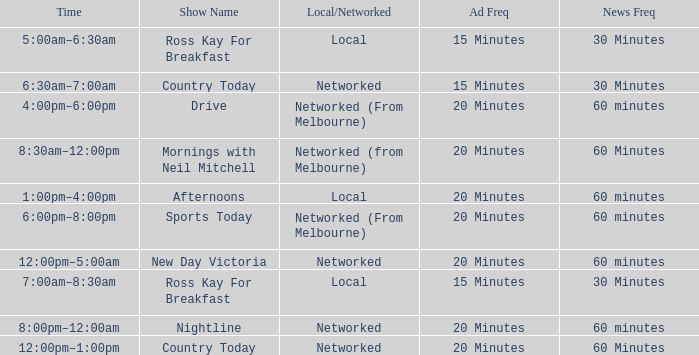What Time has a Show Name of mornings with neil mitchell? 8:30am–12:00pm. 